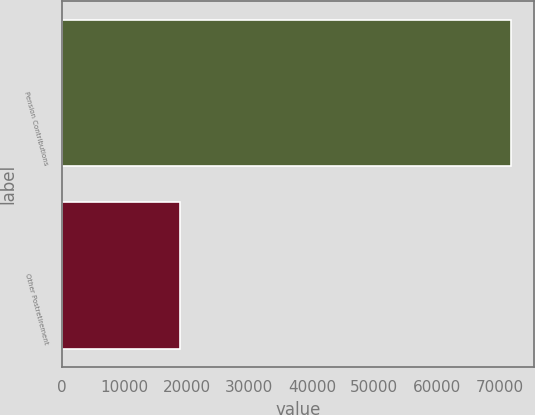<chart> <loc_0><loc_0><loc_500><loc_500><bar_chart><fcel>Pension Contributions<fcel>Other Postretirement<nl><fcel>71917<fcel>18962<nl></chart> 